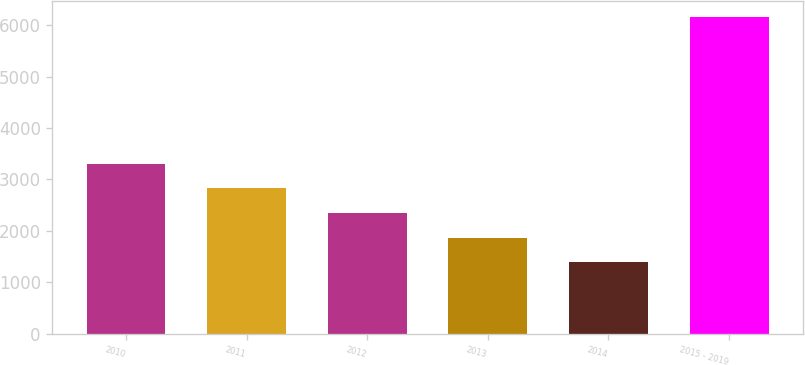Convert chart to OTSL. <chart><loc_0><loc_0><loc_500><loc_500><bar_chart><fcel>2010<fcel>2011<fcel>2012<fcel>2013<fcel>2014<fcel>2015 - 2019<nl><fcel>3302<fcel>2824.5<fcel>2347<fcel>1869.5<fcel>1392<fcel>6167<nl></chart> 